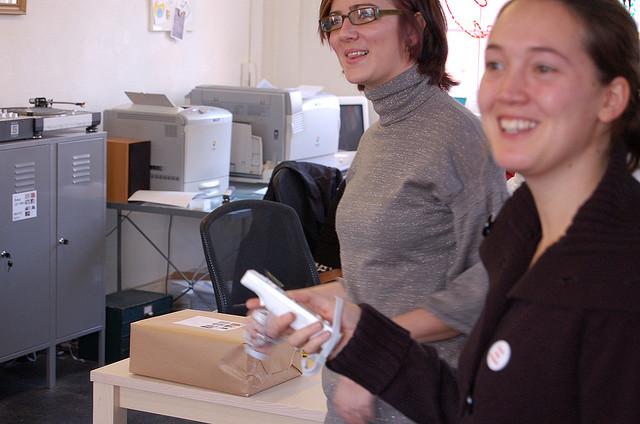Is this a Nintendo Wii controller?
Answer briefly. Yes. What color is the locker?
Quick response, please. Gray. What are the women doing in the office?
Answer briefly. Playing wii. 